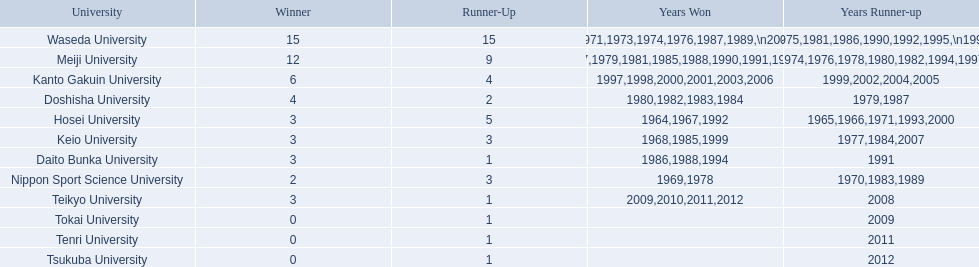What are all of the universities? Waseda University, Meiji University, Kanto Gakuin University, Doshisha University, Hosei University, Keio University, Daito Bunka University, Nippon Sport Science University, Teikyo University, Tokai University, Tenri University, Tsukuba University. And their scores? 15, 12, 6, 4, 3, 3, 3, 2, 3, 0, 0, 0. Which university scored won the most? Waseda University. 